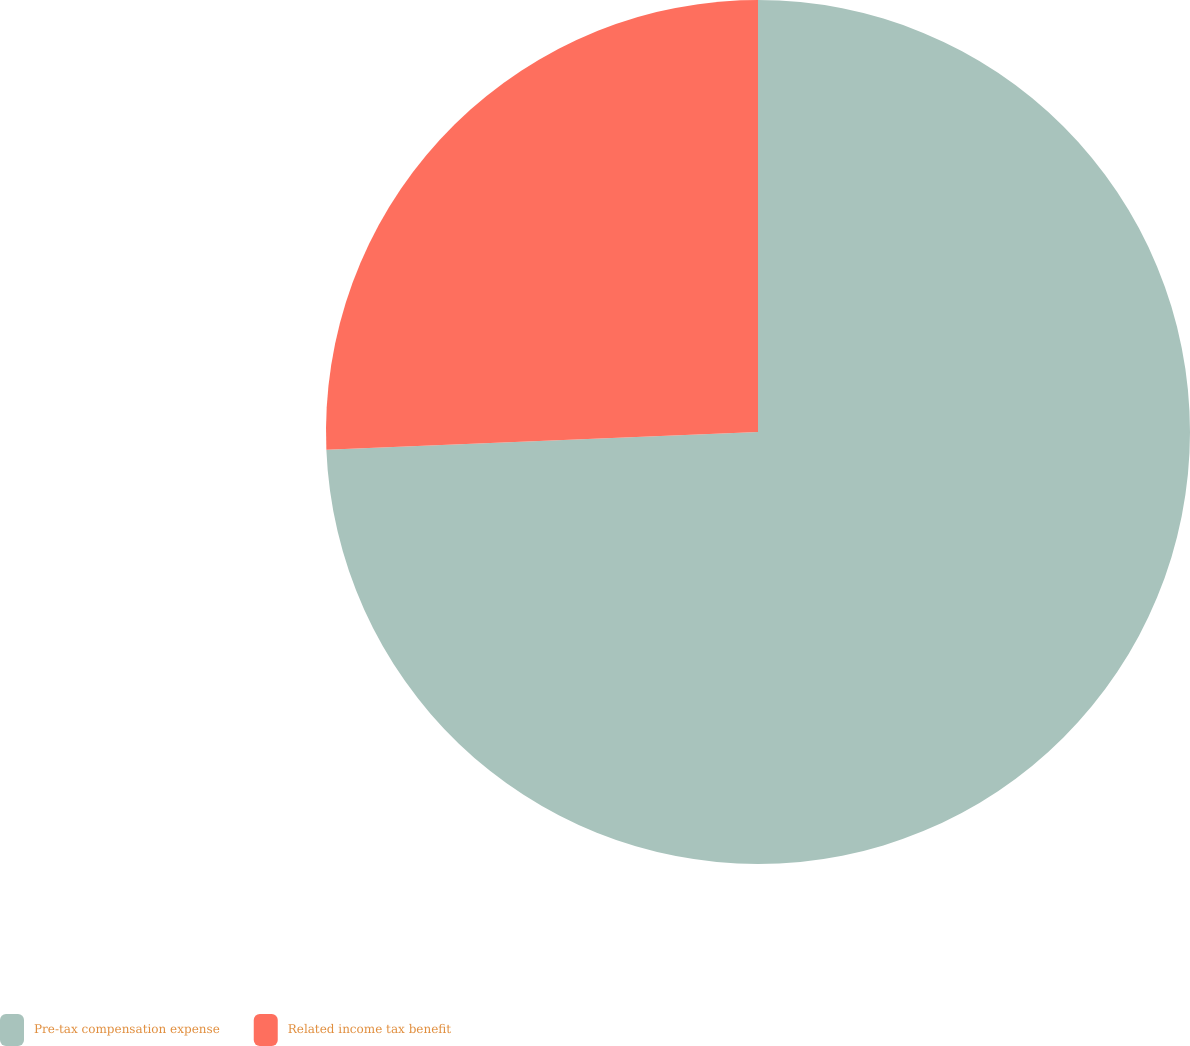Convert chart. <chart><loc_0><loc_0><loc_500><loc_500><pie_chart><fcel>Pre-tax compensation expense<fcel>Related income tax benefit<nl><fcel>74.35%<fcel>25.65%<nl></chart> 